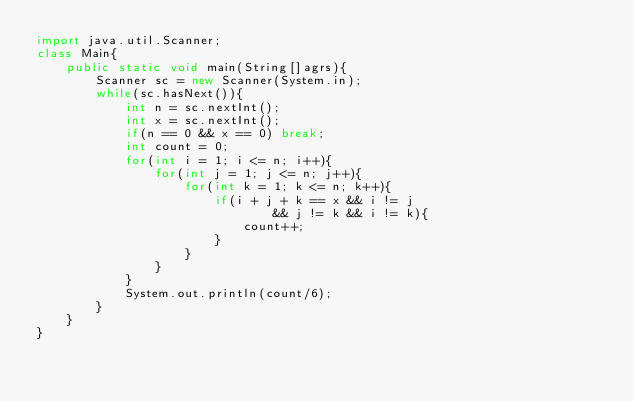Convert code to text. <code><loc_0><loc_0><loc_500><loc_500><_Java_>import java.util.Scanner;
class Main{
	public static void main(String[]agrs){
		Scanner sc = new Scanner(System.in);
		while(sc.hasNext()){
			int n = sc.nextInt();
			int x = sc.nextInt();
			if(n == 0 && x == 0) break;
			int count = 0;
			for(int i = 1; i <= n; i++){
				for(int j = 1; j <= n; j++){
					for(int k = 1; k <= n; k++){
						if(i + j + k == x && i != j
								&& j != k && i != k){
							count++;
						}
					}
				}
			}
			System.out.println(count/6);
		}
	}
}</code> 